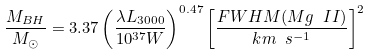Convert formula to latex. <formula><loc_0><loc_0><loc_500><loc_500>\frac { M _ { B H } } { M _ { \odot } } = 3 . 3 7 \left ( \frac { \lambda L _ { 3 0 0 0 } } { 1 0 ^ { 3 7 } W } \right ) ^ { 0 . 4 7 } \left [ \frac { F W H M ( M g \ I I ) } { k m \ s ^ { - 1 } } \right ] ^ { 2 }</formula> 